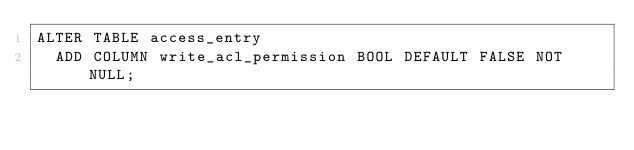<code> <loc_0><loc_0><loc_500><loc_500><_SQL_>ALTER TABLE access_entry
  ADD COLUMN write_acl_permission BOOL DEFAULT FALSE NOT NULL;
</code> 